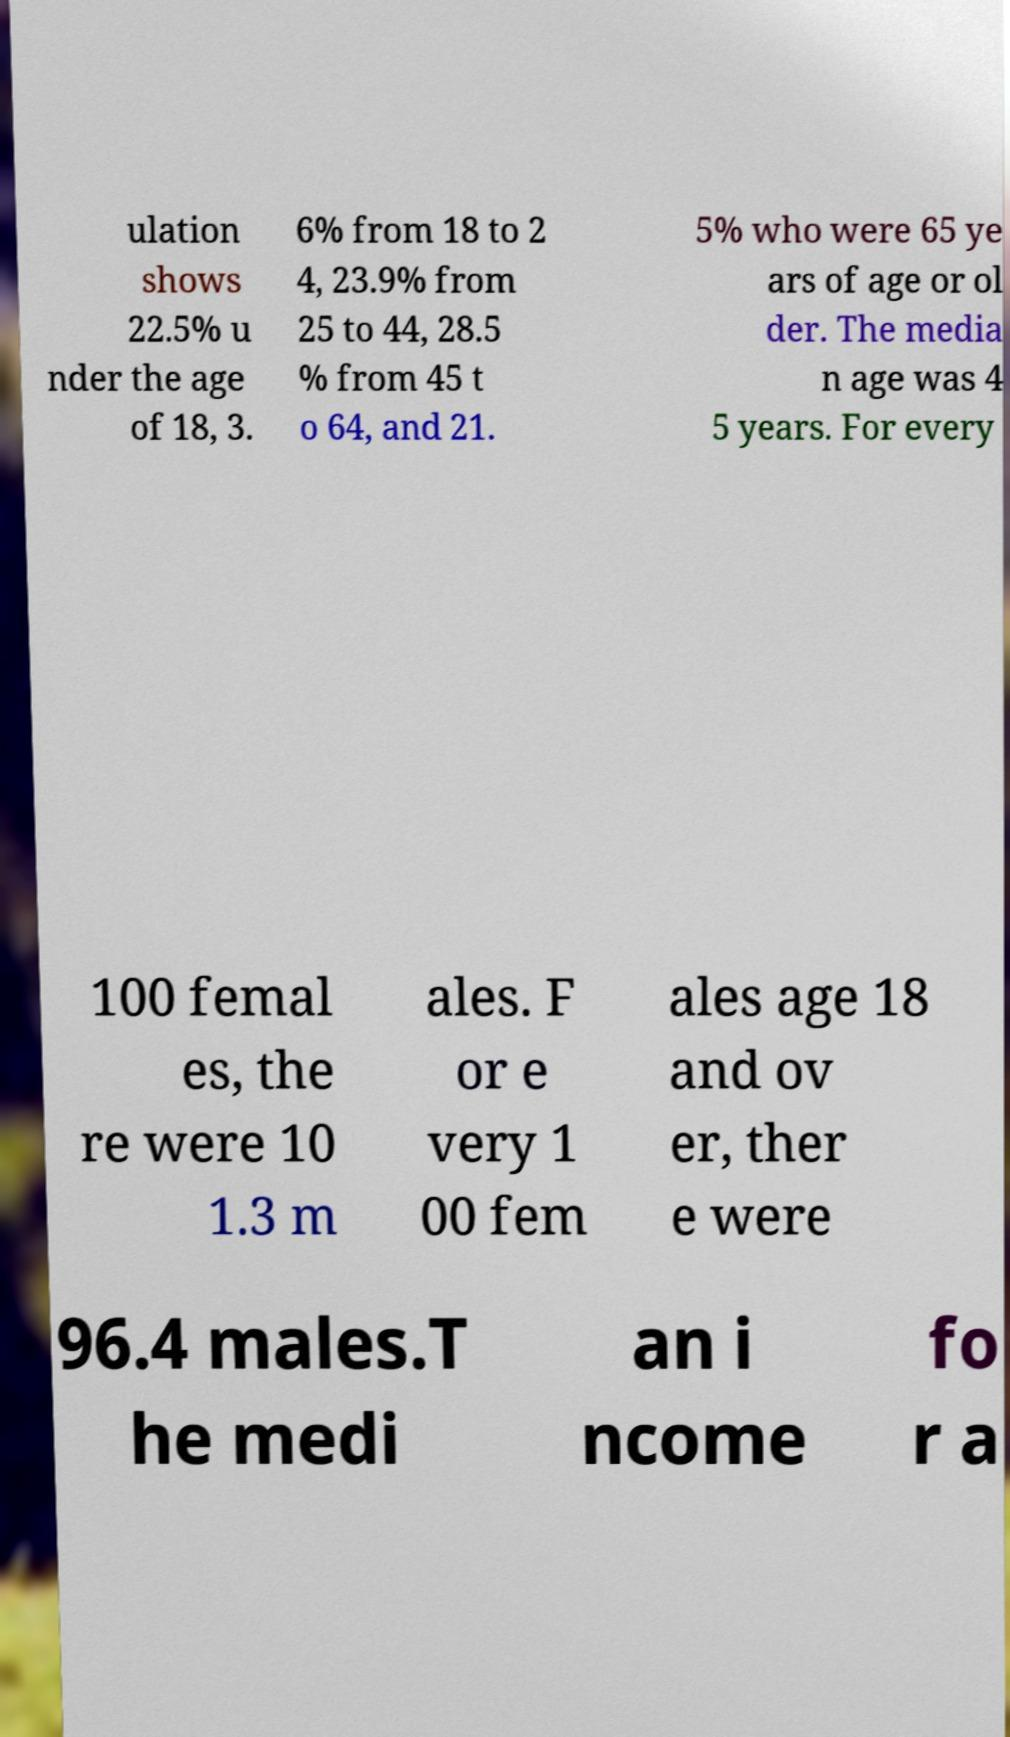Can you accurately transcribe the text from the provided image for me? ulation shows 22.5% u nder the age of 18, 3. 6% from 18 to 2 4, 23.9% from 25 to 44, 28.5 % from 45 t o 64, and 21. 5% who were 65 ye ars of age or ol der. The media n age was 4 5 years. For every 100 femal es, the re were 10 1.3 m ales. F or e very 1 00 fem ales age 18 and ov er, ther e were 96.4 males.T he medi an i ncome fo r a 